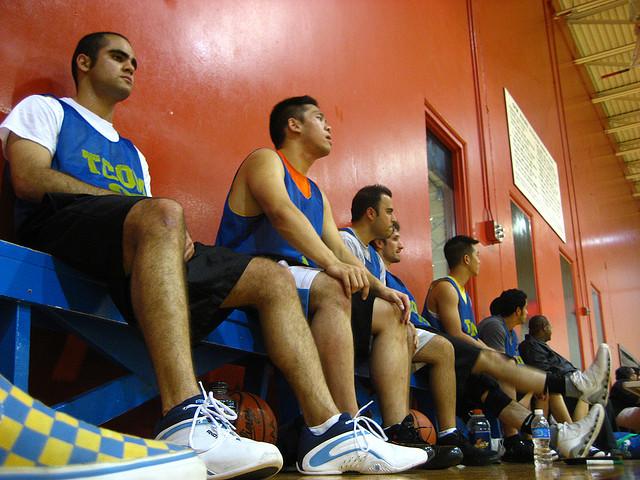Are they in a gym?
Concise answer only. Yes. How many players are here?
Give a very brief answer. 8. What color is the wall?
Give a very brief answer. Red. Are these men dressed in uniforms?
Write a very short answer. Yes. 